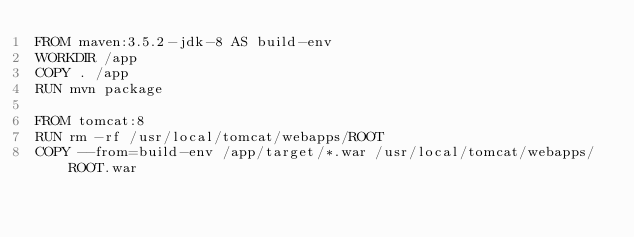<code> <loc_0><loc_0><loc_500><loc_500><_Dockerfile_>FROM maven:3.5.2-jdk-8 AS build-env
WORKDIR /app
COPY . /app
RUN mvn package

FROM tomcat:8
RUN rm -rf /usr/local/tomcat/webapps/ROOT
COPY --from=build-env /app/target/*.war /usr/local/tomcat/webapps/ROOT.war</code> 